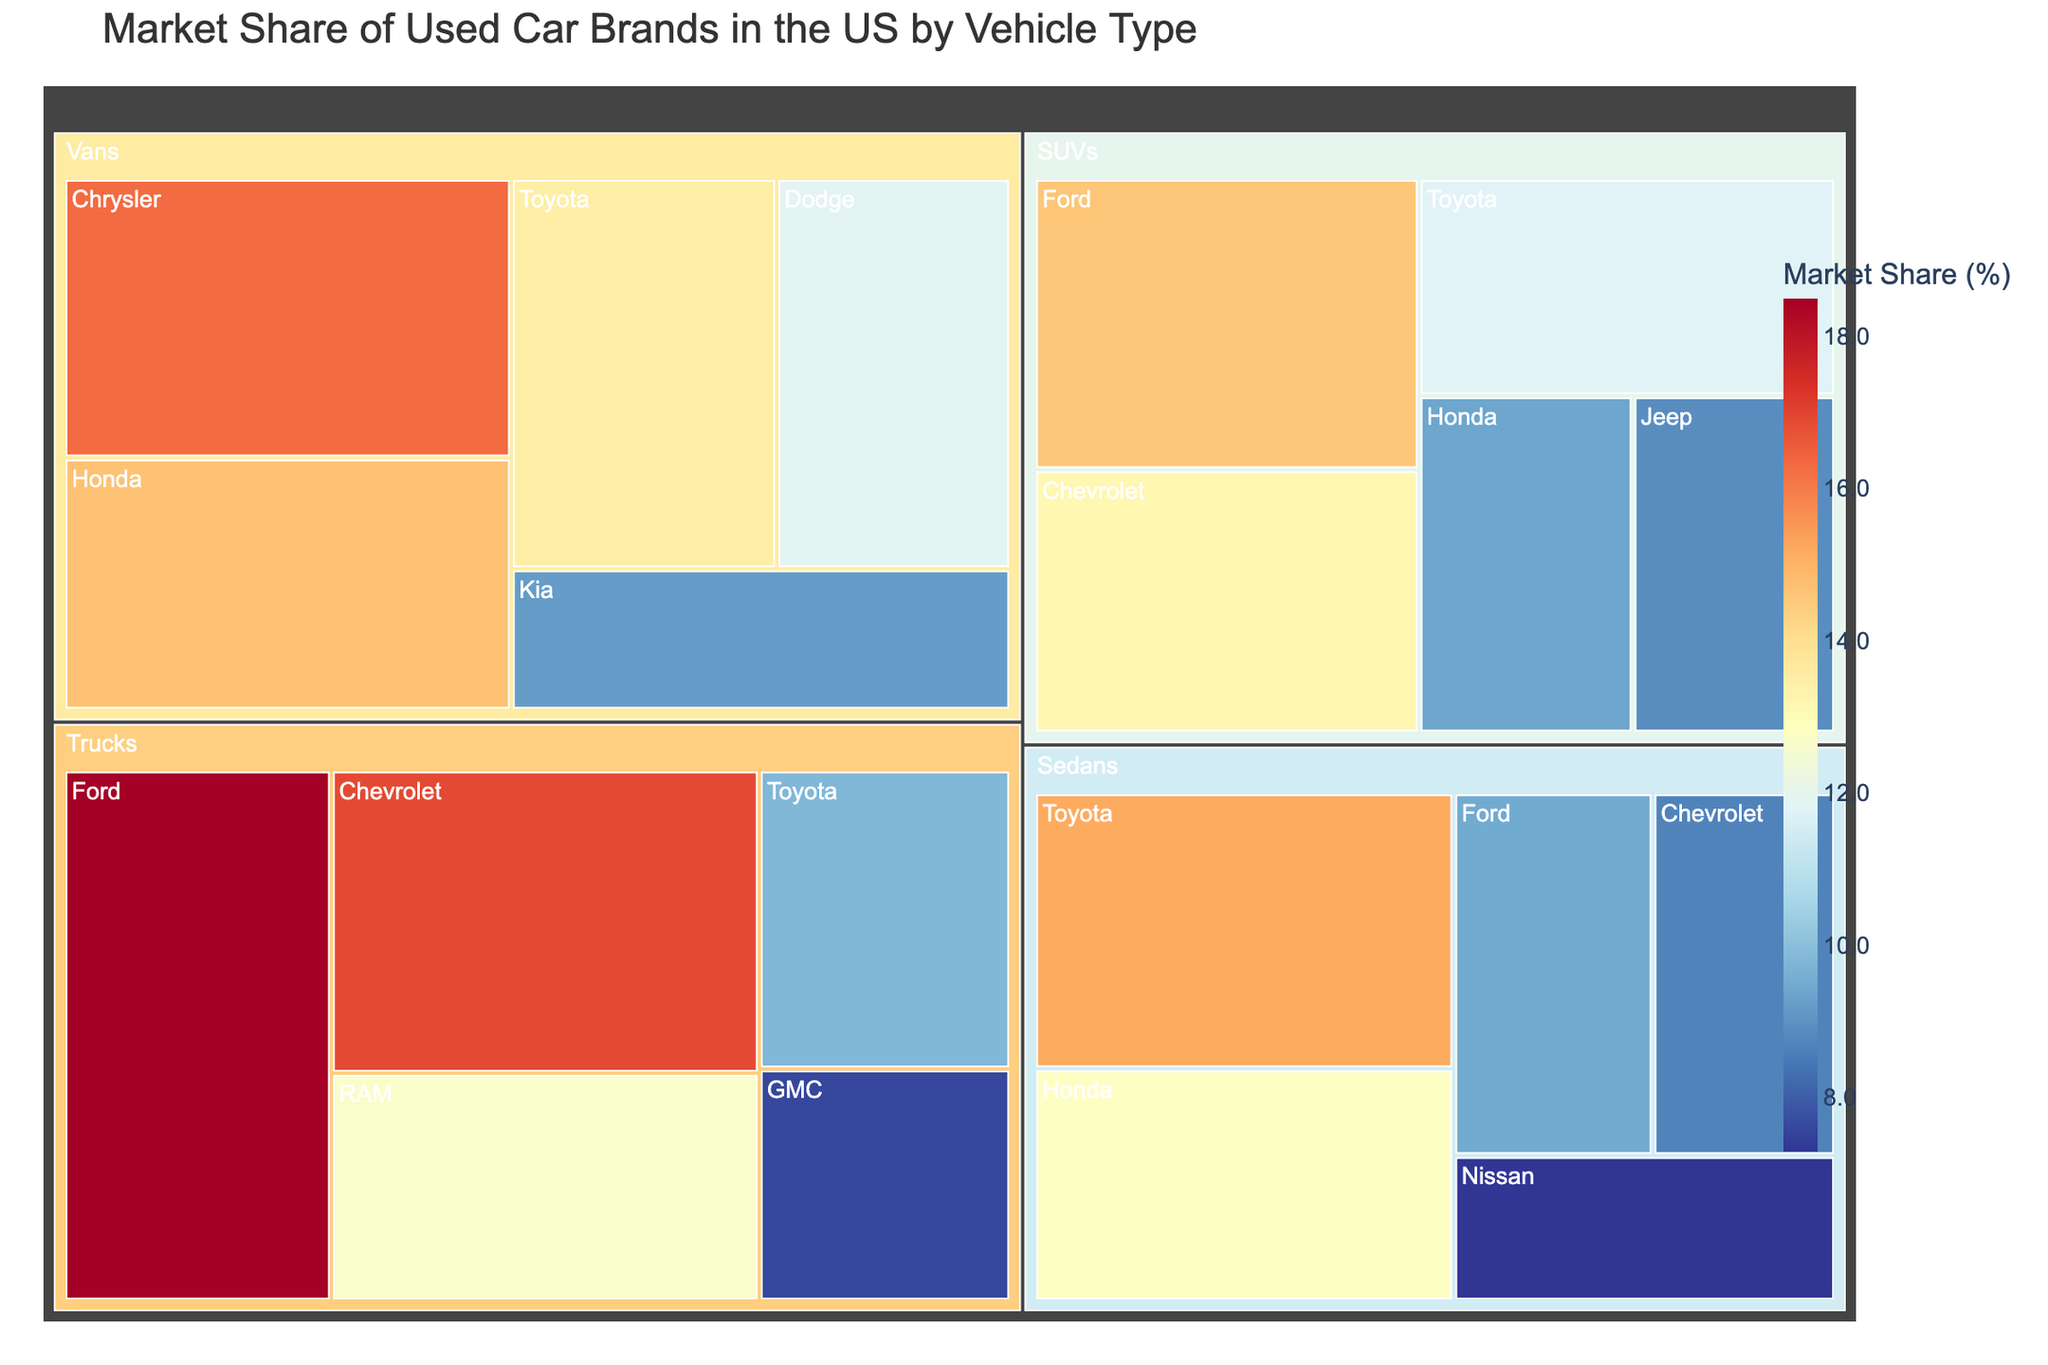What is the market share of Toyota in the sedan category? To find the market share of Toyota in the sedan category, locate the Toyota section within the "Sedans" grouping and note its market share value.
Answer: 15.2% Which vehicle type has the highest market share for Ford? Identify all vehicle types listing Ford and compare their market share values: Sedans (9.5), SUVs (14.6), and Trucks (18.5). Trucks have the highest market share.
Answer: Trucks How does Chrysler's market share in vans compare to Kia's? Locate Chrysler and Kia in the "Vans" section, then compare their market share values. Chrysler has 16.3%, while Kia has 9.2%.
Answer: Chrysler has a higher market share What is the combined market share of Honda and Toyota in the SUV category? Locate Honda and Toyota within the "SUVs" grouping and add their market share values: 9.4% (Honda) + 11.8% (Toyota) = 21.2%.
Answer: 21.2% Which brand has the smallest market share in the truck category? Identify all brands in the "Trucks" section and determine the smallest market share value among them: Ford (18.5), Chevrolet (16.9), RAM (12.7), Toyota (9.8), GMC (7.6). GMC has the smallest market share.
Answer: GMC What is the difference in market share between Honda in vans and Honda in sedans? Locate Honda in both "Vans" and "Sedans" sections, then subtract the sedan's market share from the van's: 14.7% (Vans) - 12.8% (Sedans) = 1.9%.
Answer: 1.9% Which vehicle type accounts for the largest market share of used car brands in the US? Compare the market share values for the main vehicle types (Sedans, SUVs, Trucks, Vans) by adding up the market shares of the brands within each type. SUVs appear to represent the highest total combined market share.
Answer: SUVs What is the difference in market share between the highest and lowest market shares within the sedan category? Identify the highest (Toyota, 15.2) and lowest (Nissan, 7.3) market shares within the Sedans section, then calculate the difference: 15.2% - 7.3% = 7.9%.
Answer: 7.9% Which brand has the highest overall market share across all vehicle types? Compare the highest individual market share values across all categories to determine the highest one: Ford (18.5 in Trucks).
Answer: Ford What is the average market share of brands in the van category? Add the market share values of brands in the "Vans" section and divide by the number of brands: (16.3 + 14.7 + 13.5 + 11.9 + 9.2) / 5 = 13.12%.
Answer: 13.12% 